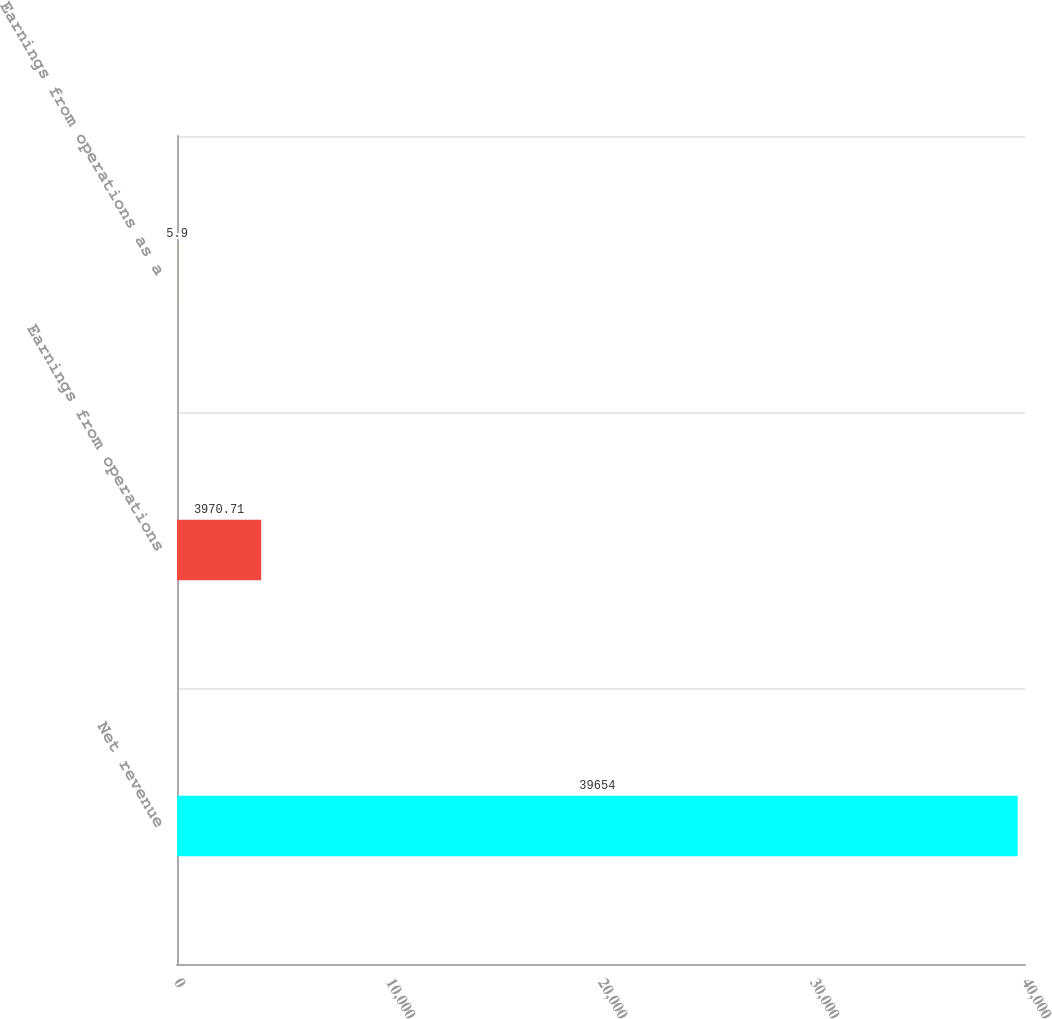<chart> <loc_0><loc_0><loc_500><loc_500><bar_chart><fcel>Net revenue<fcel>Earnings from operations<fcel>Earnings from operations as a<nl><fcel>39654<fcel>3970.71<fcel>5.9<nl></chart> 